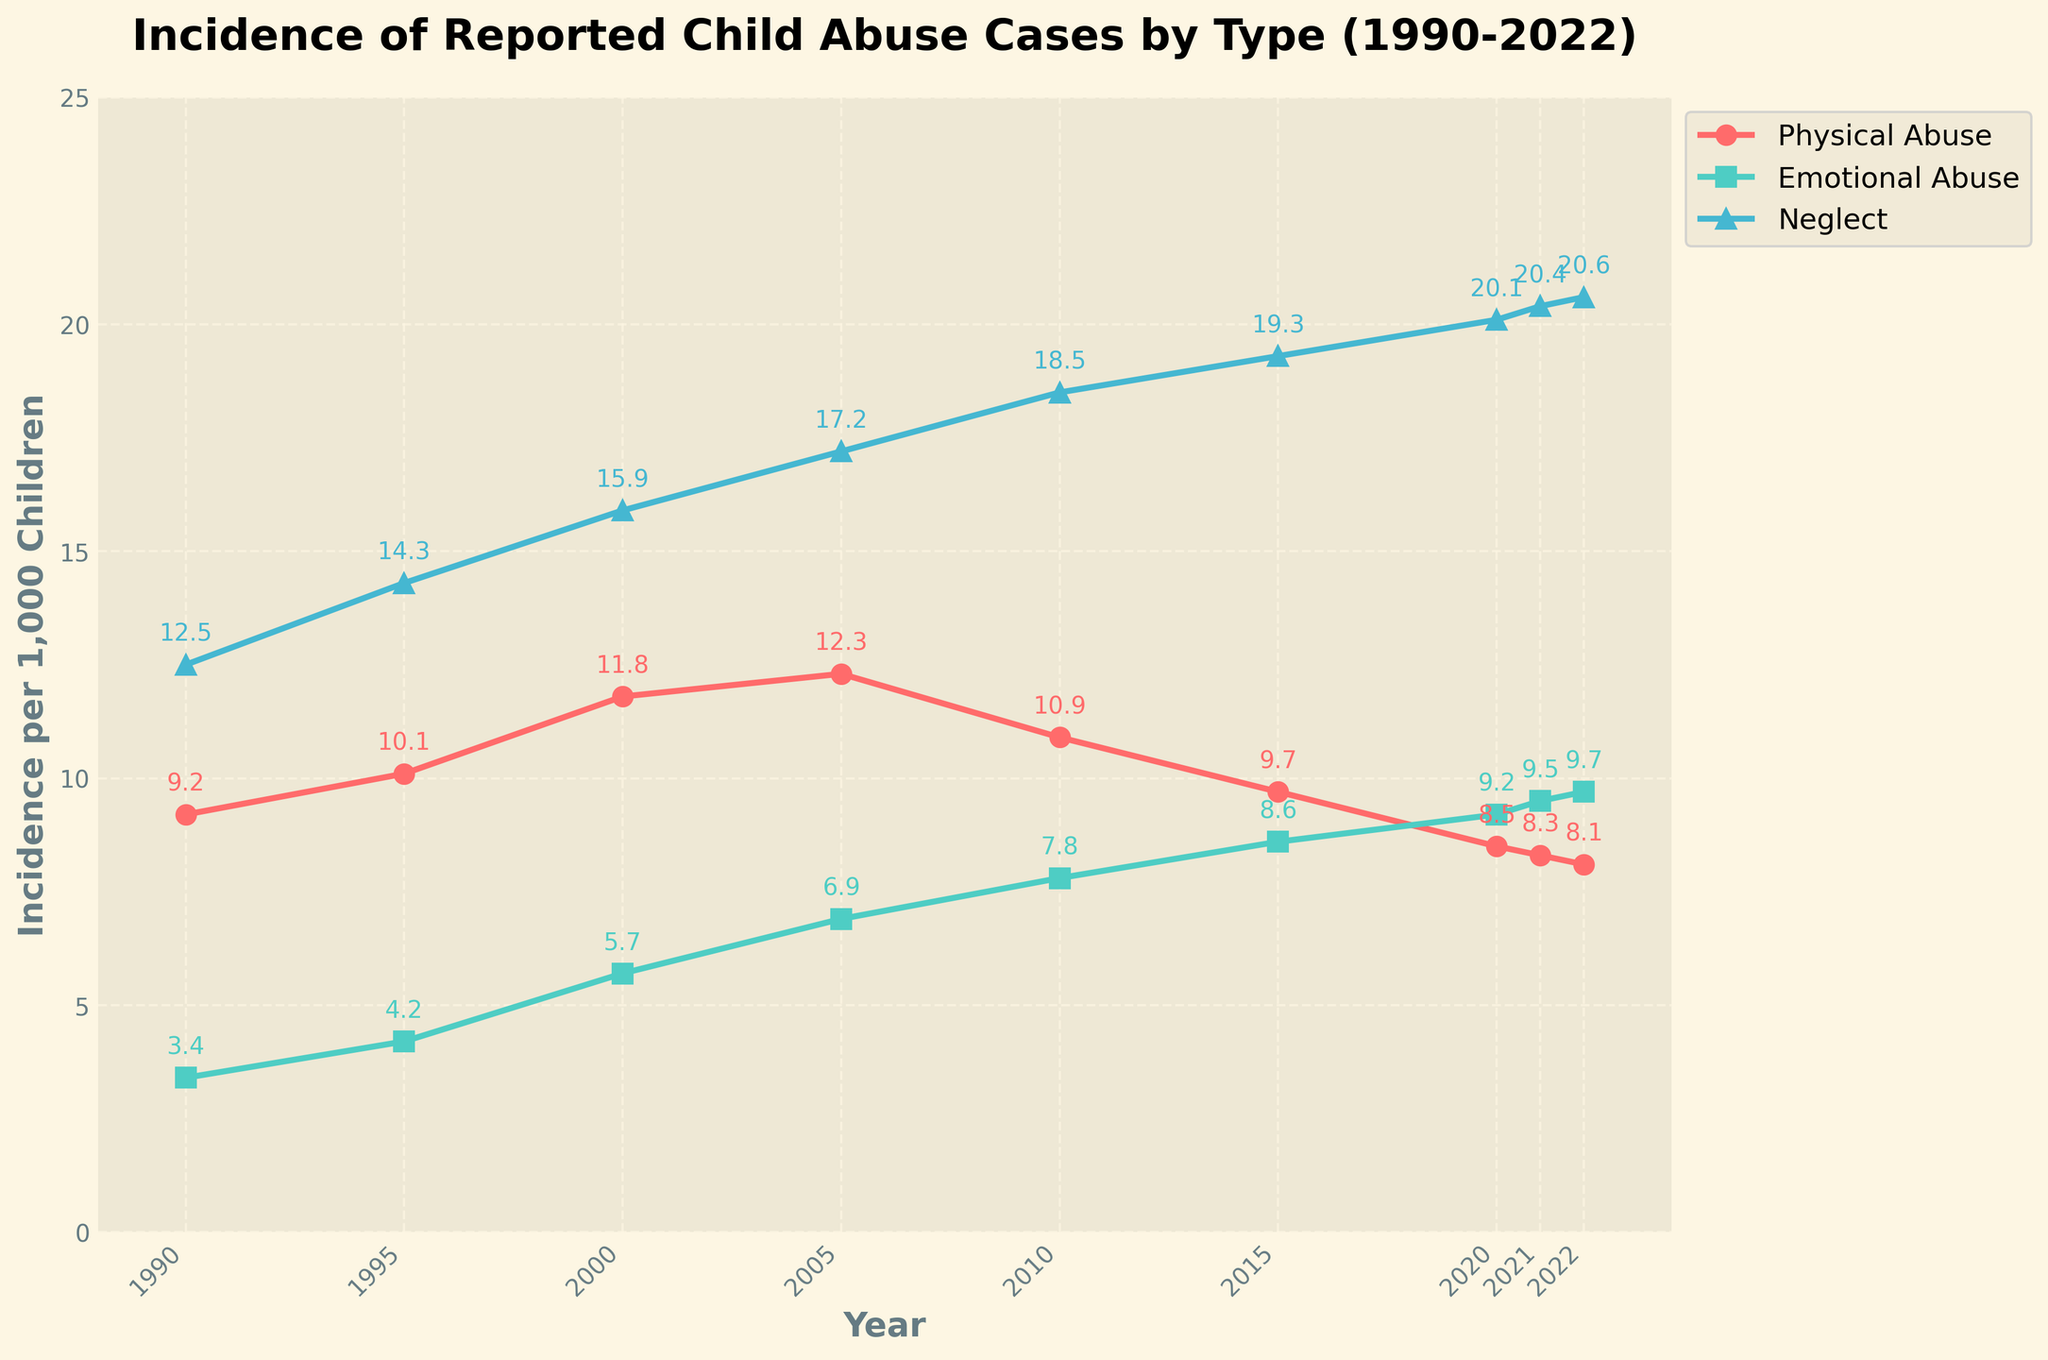What is the trend in the incidence of emotional abuse from 1990 to 2022? The line chart shows the incidence of emotional abuse rising steadily from 3.4 in 1990 to 9.7 in 2022.
Answer: Steadily increasing How does the rate of physical abuse in 2022 compare to the rate in 1990? In 1990, the incidence of physical abuse was 9.2. By 2022, it had decreased to 8.1.
Answer: Decreased Which type of abuse showed an overall increase over the three decades? By examining the slope of the lines, we can see that emotional abuse and neglect have increased, while physical abuse has decreased.
Answer: Emotional abuse and neglect In what year did neglect first surpass 15 cases per 1,000 children? The line for neglect first goes above 15 cases per 1,000 children in the year 2000.
Answer: 2000 How much did the incidence of neglect increase from 1990 to 2022? The incidence of neglect was 12.5 in 1990 and rose to 20.6 in 2022. The increase is calculated as \(20.6 - 12.5\).
Answer: 8.1 Compare the rates of emotional abuse and neglect in the year 2005. Which was higher and by how much? In 2005, the incidence of emotional abuse was 6.9, and neglect was 17.2. The difference is \(17.2 - 6.9\).
Answer: Neglect by 10.3 What is the average incidence rate of physical abuse over the three decades? The average can be found by summing all the incidence rates of physical abuse and dividing by the number of years: \((9.2 + 10.1 + 11.8 + 12.3 + 10.9 + 9.7 + 8.5 + 8.3 + 8.1)/9\).
Answer: 9.87 In which year did emotional abuse first reach or exceed the incidence rate of physical abuse? Looking at the graph, the first year when the line for emotional abuse surpasses the line for physical abuse is 2015.
Answer: 2015 Which year had the highest overall recorded incidence of neglect, and what was the rate? By examining the highest point on the neglect line, the maximum recorded incidence of neglect was in 2022 at a rate of 20.6.
Answer: 2022, 20.6 Are the trends in the incidence of physical abuse and emotional abuse converging, diverging, or remaining parallel from 1990 to 2022? The lines representing physical and emotional abuse are converging over time, as physical abuse is decreasing while emotional abuse is increasing.
Answer: Converging 